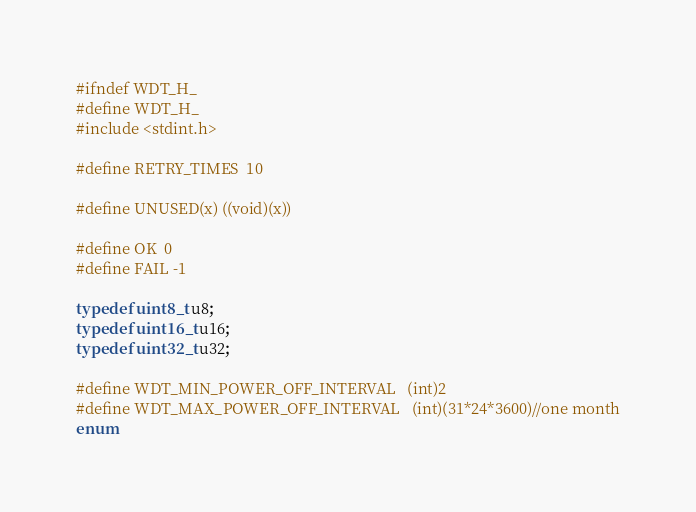Convert code to text. <code><loc_0><loc_0><loc_500><loc_500><_C_>#ifndef WDT_H_
#define WDT_H_
#include <stdint.h>

#define RETRY_TIMES	10

#define UNUSED(x) ((void)(x))  

#define OK  0
#define FAIL -1

typedef uint8_t u8;
typedef uint16_t u16;
typedef uint32_t u32;

#define WDT_MIN_POWER_OFF_INTERVAL	(int)2
#define WDT_MAX_POWER_OFF_INTERVAL	(int)(31*24*3600)//one month
enum</code> 